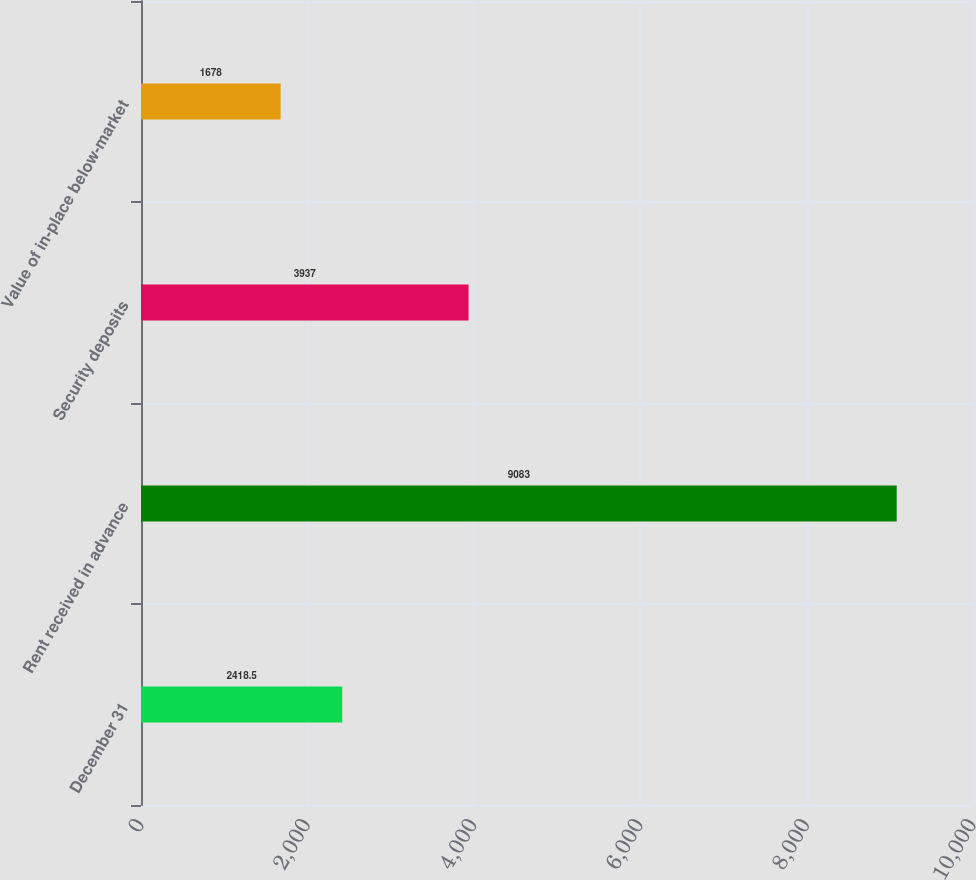Convert chart to OTSL. <chart><loc_0><loc_0><loc_500><loc_500><bar_chart><fcel>December 31<fcel>Rent received in advance<fcel>Security deposits<fcel>Value of in-place below-market<nl><fcel>2418.5<fcel>9083<fcel>3937<fcel>1678<nl></chart> 